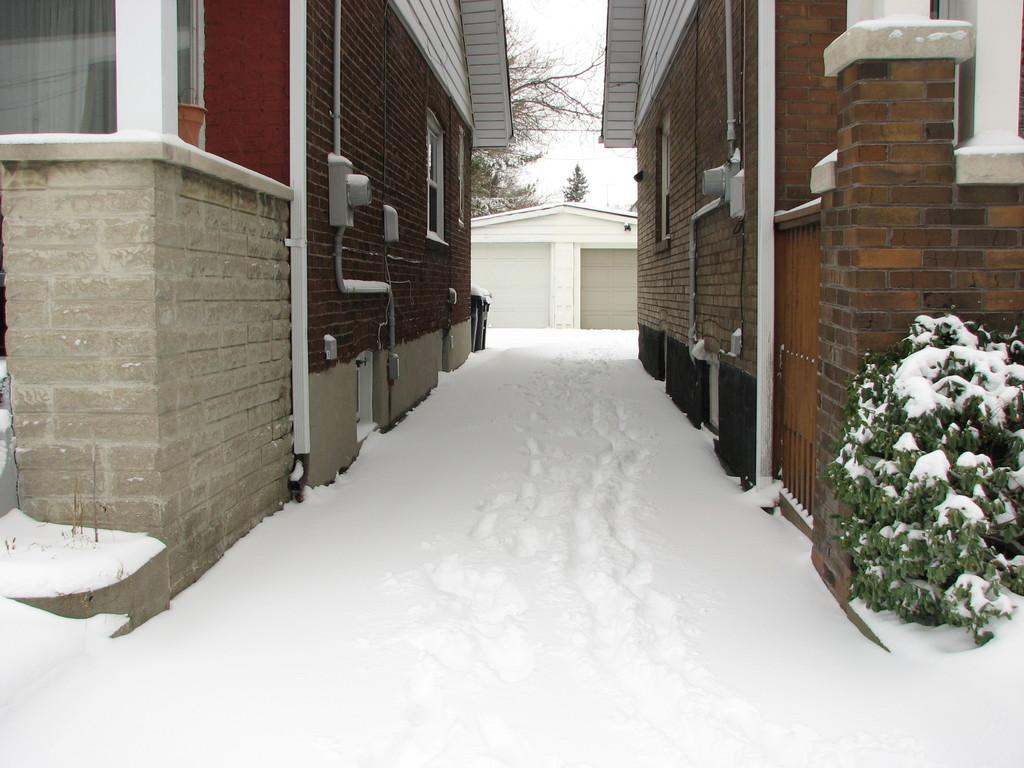How many houses can be seen in the image? There are two houses in the image. What is the condition of the land around the houses? The land around the houses is covered with snow. What can be seen in the background of the image? There is a sky and trees visible in the background of the image. What type of cast can be seen on the side of one of the houses in the image? There is no cast present on the side of any of the houses in the image. 